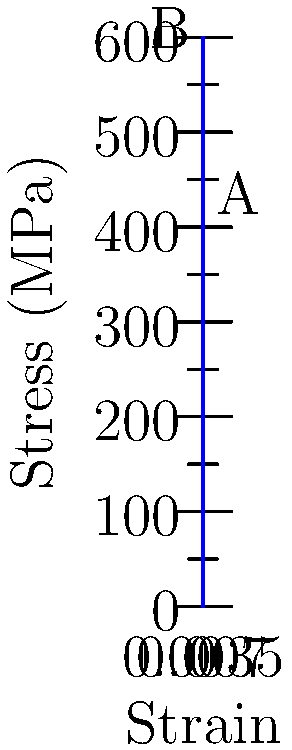As a handyman, you're often working with metal rods for various projects. Looking at the stress-strain diagram for a metal rod you frequently use, what is the approximate tensile strength of the rod in MPa? Assume the rod has a diameter of 10 mm and fails at point B on the diagram. To solve this problem, we'll follow these steps:

1. Identify the tensile strength:
   The tensile strength is the maximum stress the material can withstand before failure. On a stress-strain diagram, this is typically the highest point on the curve before fracture.

2. Locate the failure point:
   The question states that the rod fails at point B on the diagram.

3. Read the stress value at point B:
   From the y-axis (stress axis) of the diagram, we can see that point B corresponds to a stress value of approximately 575 MPa.

4. Conclusion:
   The tensile strength of the metal rod is the stress value at point B, which is 575 MPa.

Note: The diameter of the rod (10 mm) is not needed for this calculation, as the stress-strain diagram already provides the stress values in MPa, which are independent of the cross-sectional area.
Answer: 575 MPa 